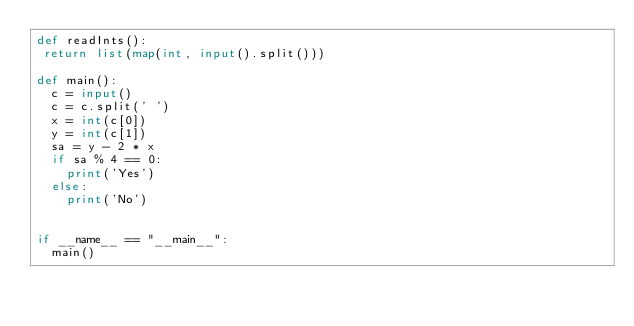<code> <loc_0><loc_0><loc_500><loc_500><_Python_>def readInts():
 return list(map(int, input().split()))

def main():
  c = input()
  c = c.split(' ')
  x = int(c[0])
  y = int(c[1])
  sa = y - 2 * x
  if sa % 4 == 0:
    print('Yes')
  else:
    print('No')
  
  
if __name__ == "__main__":
  main()</code> 